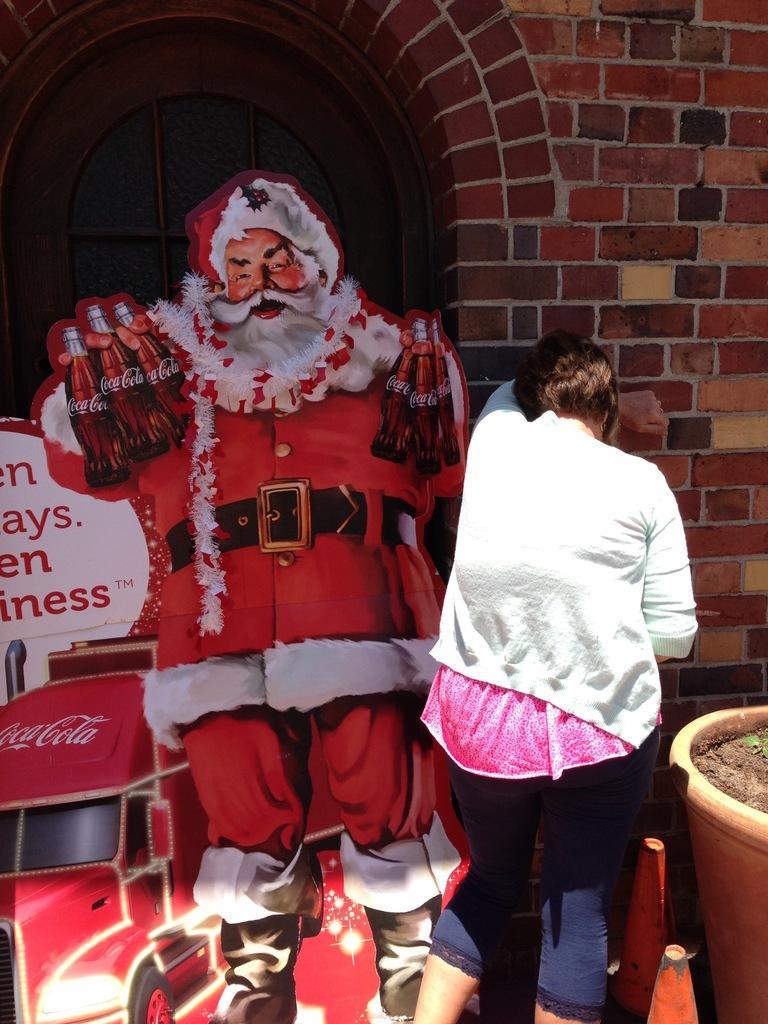Can you describe this image briefly? This image is taken outdoors. In the background there is a wall. On the right side of the image there is a pot and there are two safety cones and there is a woman. On the left side of the image there is a banner with an image of a Santa-claus, a truck and there is a text on it. 